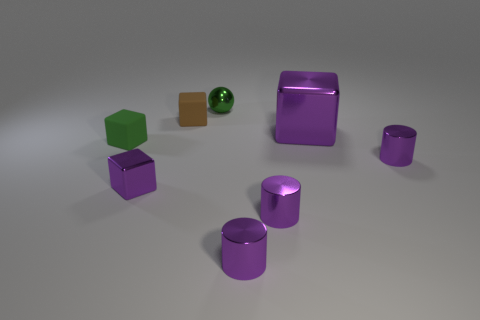Add 1 purple cylinders. How many objects exist? 9 Subtract all small green cubes. How many cubes are left? 3 Subtract all purple blocks. How many blocks are left? 2 Subtract 0 gray cubes. How many objects are left? 8 Subtract all balls. How many objects are left? 7 Subtract 4 cubes. How many cubes are left? 0 Subtract all yellow cubes. Subtract all yellow balls. How many cubes are left? 4 Subtract all blue cylinders. How many purple blocks are left? 2 Subtract all red spheres. Subtract all brown objects. How many objects are left? 7 Add 3 matte objects. How many matte objects are left? 5 